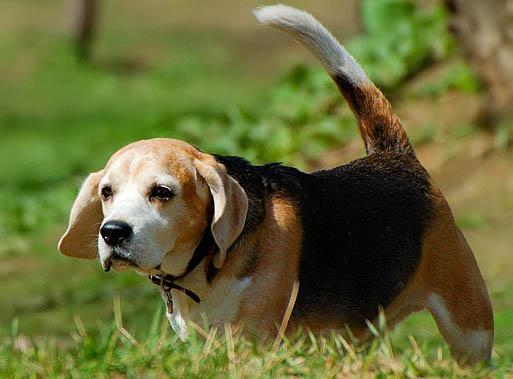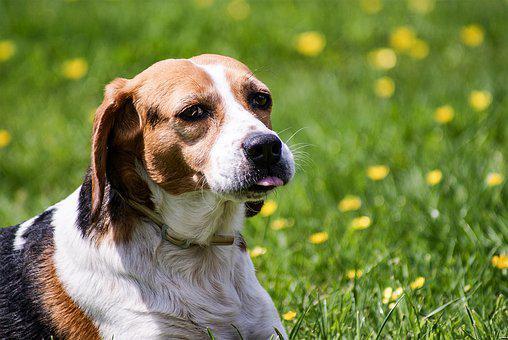The first image is the image on the left, the second image is the image on the right. Evaluate the accuracy of this statement regarding the images: "One of the puppies is running through the grass.". Is it true? Answer yes or no. No. 